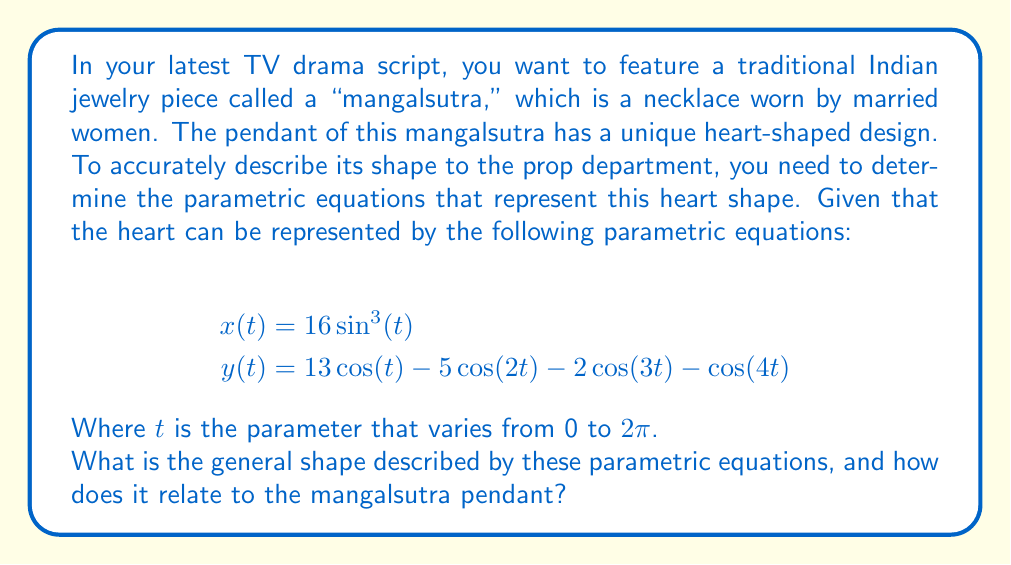Teach me how to tackle this problem. To determine the shape described by these parametric equations, we need to analyze their behavior:

1. First, let's consider the range of the parameter $t$: $0 \leq t \leq 2\pi$

2. The $x(t)$ equation:
   $$x(t) = 16\sin^3(t)$$
   This equation creates a symmetric shape about the y-axis, as $\sin^3(t)$ is an odd function.

3. The $y(t)$ equation:
   $$y(t) = 13\cos(t) - 5\cos(2t) - 2\cos(3t) - \cos(4t)$$
   This is a combination of cosine functions with different frequencies and amplitudes.

4. To visualize the shape, we can plot these equations for various values of $t$:

[asy]
import graph;
size(200);

real x(real t) {return 16*sin(t)^3;}
real y(real t) {return 13*cos(t) - 5*cos(2*t) - 2*cos(3*t) - cos(4*t);}

path heart = graph(x, y, 0, 2*pi, 200);
draw(heart, red);

xaxis("x", arrow=Arrow);
yaxis("y", arrow=Arrow);
[/asy]

5. The resulting shape is indeed a heart, which is perfect for the mangalsutra pendant.

6. Key features of this heart shape:
   - It has a pointed bottom where the two curves meet.
   - The top has two symmetric rounded lobes.
   - The overall shape is symmetric about the y-axis.

7. In the context of the mangalsutra:
   - The heart shape symbolizes love and commitment in marriage.
   - The pointed bottom could represent the union of two individuals into one.
   - The symmetric nature reflects the balance and harmony in a marital relationship.
Answer: The parametric equations describe a heart shape, which is perfectly suited for the pendant of a mangalsutra in your TV drama script. This heart-shaped design symbolizes love and marital commitment, making it an ideal representation of the traditional Indian jewelry piece worn by married women. 